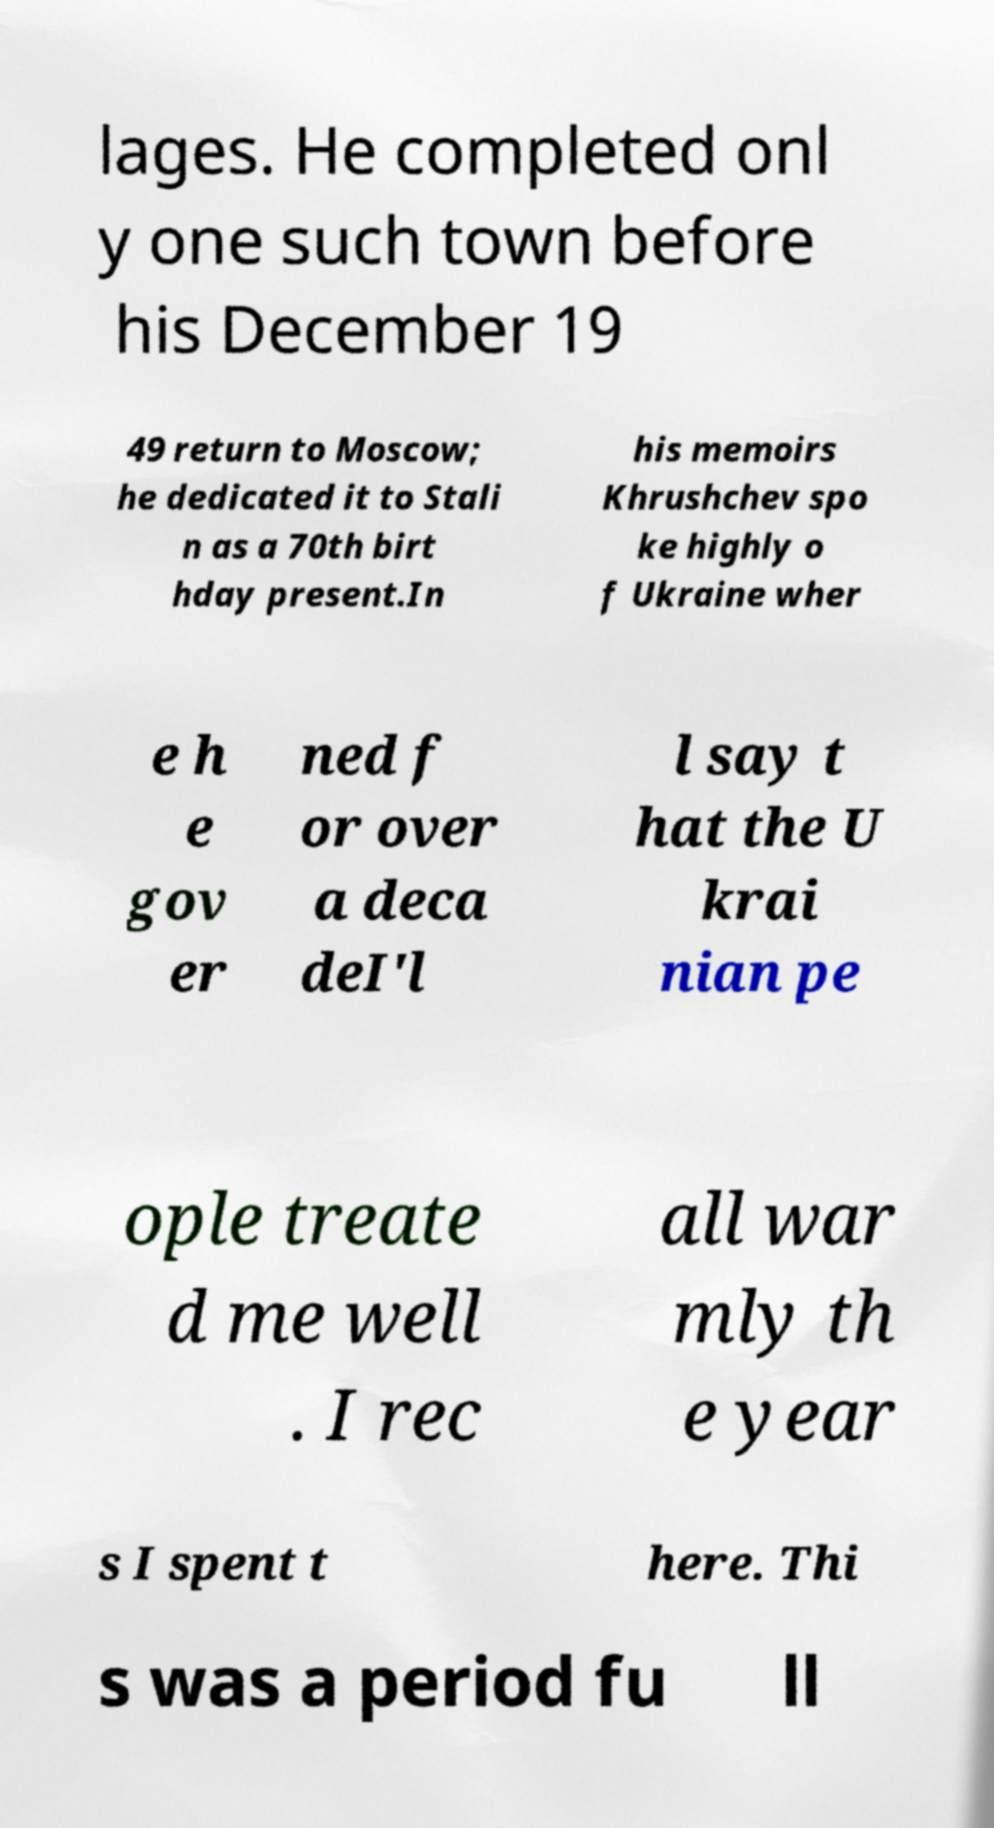What messages or text are displayed in this image? I need them in a readable, typed format. lages. He completed onl y one such town before his December 19 49 return to Moscow; he dedicated it to Stali n as a 70th birt hday present.In his memoirs Khrushchev spo ke highly o f Ukraine wher e h e gov er ned f or over a deca deI'l l say t hat the U krai nian pe ople treate d me well . I rec all war mly th e year s I spent t here. Thi s was a period fu ll 